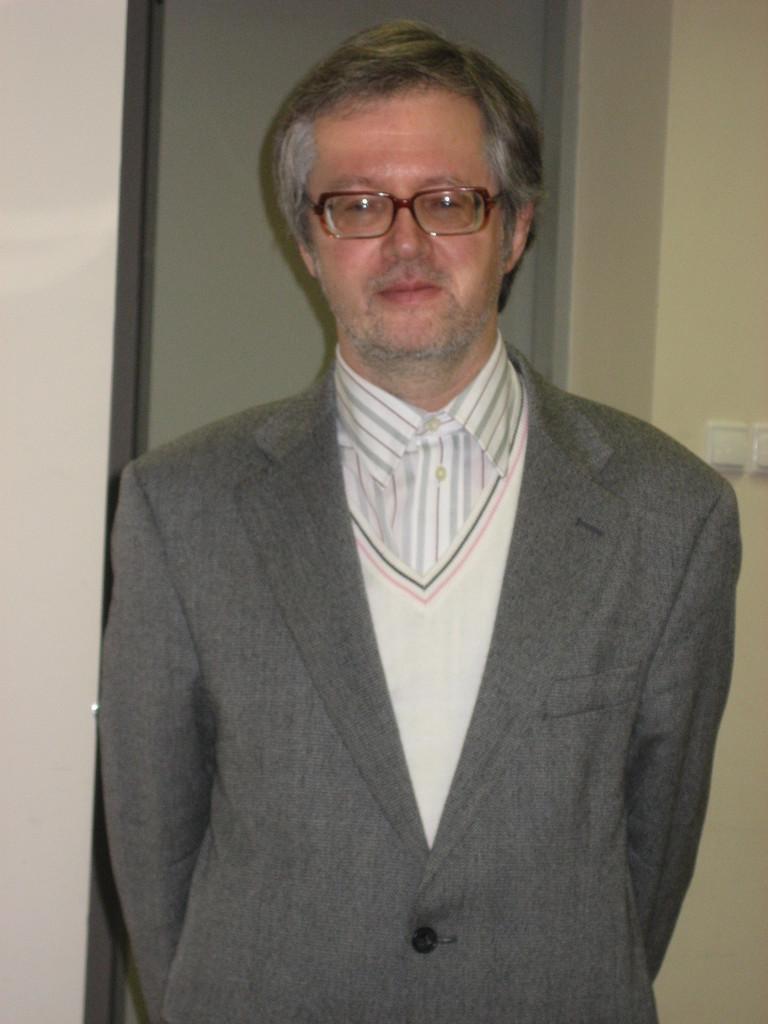In one or two sentences, can you explain what this image depicts? In this image I can see the person standing and wearing the dress which is in ash, white and pink color. In the background I can see the switches to the wall. 